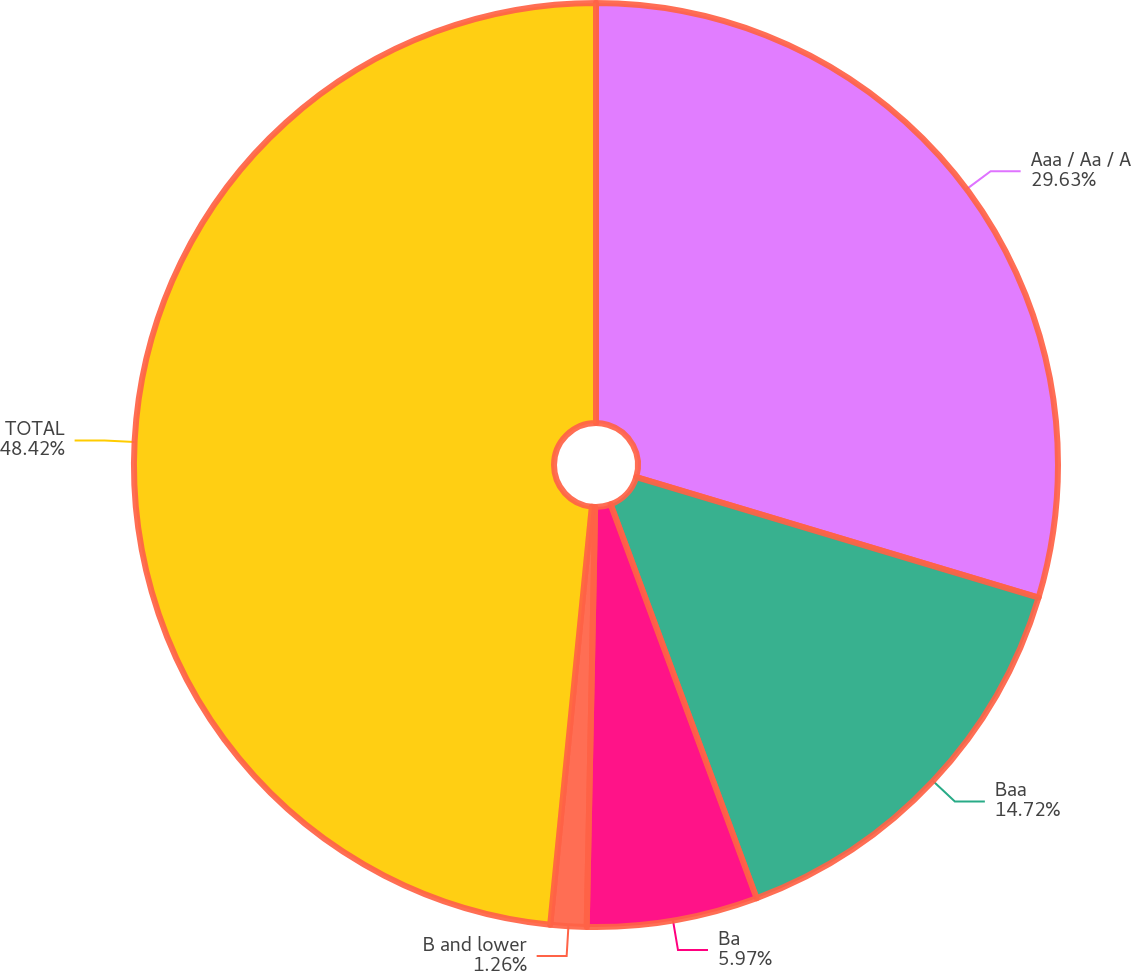Convert chart. <chart><loc_0><loc_0><loc_500><loc_500><pie_chart><fcel>Aaa / Aa / A<fcel>Baa<fcel>Ba<fcel>B and lower<fcel>TOTAL<nl><fcel>29.63%<fcel>14.72%<fcel>5.97%<fcel>1.26%<fcel>48.42%<nl></chart> 